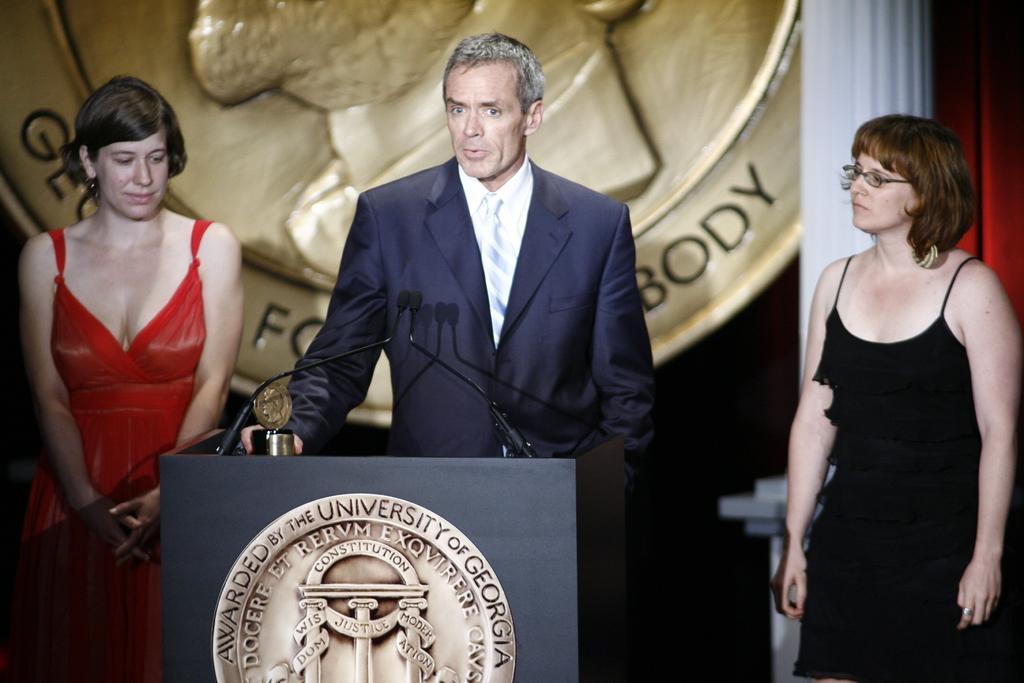Could you give a brief overview of what you see in this image? In this picture we can see a man and two women, he is holding a shield, in front of him we can see microphones and a podium. 